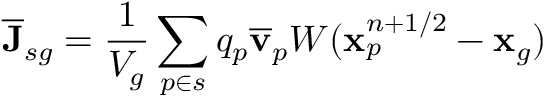Convert formula to latex. <formula><loc_0><loc_0><loc_500><loc_500>\overline { J } _ { s g } = \frac { 1 } { V _ { g } } \sum _ { p \in s } q _ { p } \overline { v } _ { p } W ( x _ { p } ^ { n + 1 / 2 } - x _ { g } )</formula> 